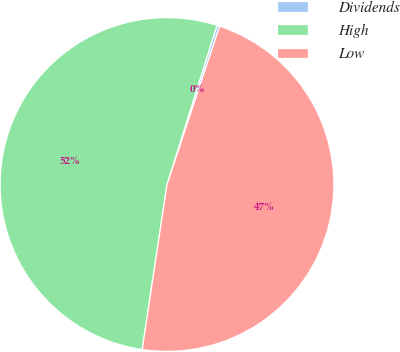Convert chart to OTSL. <chart><loc_0><loc_0><loc_500><loc_500><pie_chart><fcel>Dividends<fcel>High<fcel>Low<nl><fcel>0.27%<fcel>52.46%<fcel>47.26%<nl></chart> 